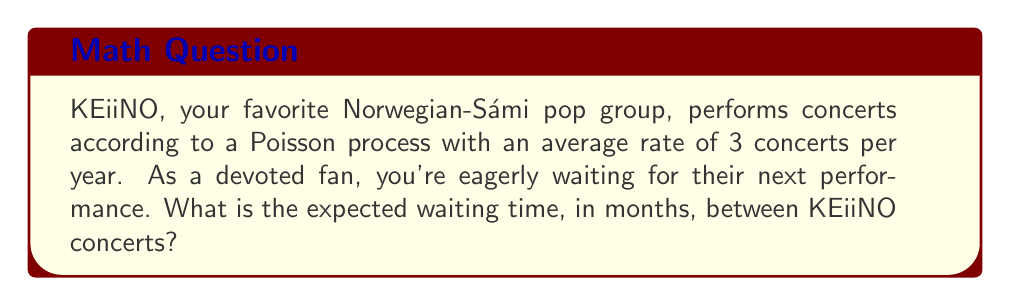Show me your answer to this math problem. Let's approach this step-by-step:

1) In a Poisson process, the waiting time between events follows an exponential distribution.

2) The rate parameter λ (lambda) for the exponential distribution is the same as the rate of the Poisson process.

3) Given: 
   - Rate of concerts = 3 per year
   - We need to convert this to months: λ = 3/12 = 0.25 concerts per month

4) For an exponential distribution, the expected value (mean waiting time) is given by:

   $$ E[X] = \frac{1}{\lambda} $$

5) Substituting our λ value:

   $$ E[X] = \frac{1}{0.25} = 4 $$

6) Therefore, the expected waiting time between concerts is 4 months.
Answer: 4 months 